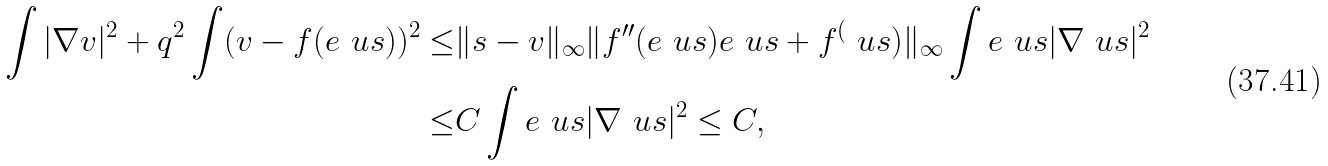Convert formula to latex. <formula><loc_0><loc_0><loc_500><loc_500>\int | \nabla v | ^ { 2 } + q ^ { 2 } \int ( v - f ( e ^ { \ } u s ) ) ^ { 2 } \leq & \| s - v \| _ { \infty } \| f ^ { \prime \prime } ( e ^ { \ } u s ) e ^ { \ } u s + f ^ { ( } \ u s ) \| _ { \infty } \int e ^ { \ } u s | \nabla \ u s | ^ { 2 } \\ \leq & C \int e ^ { \ } u s | \nabla \ u s | ^ { 2 } \leq C ,</formula> 